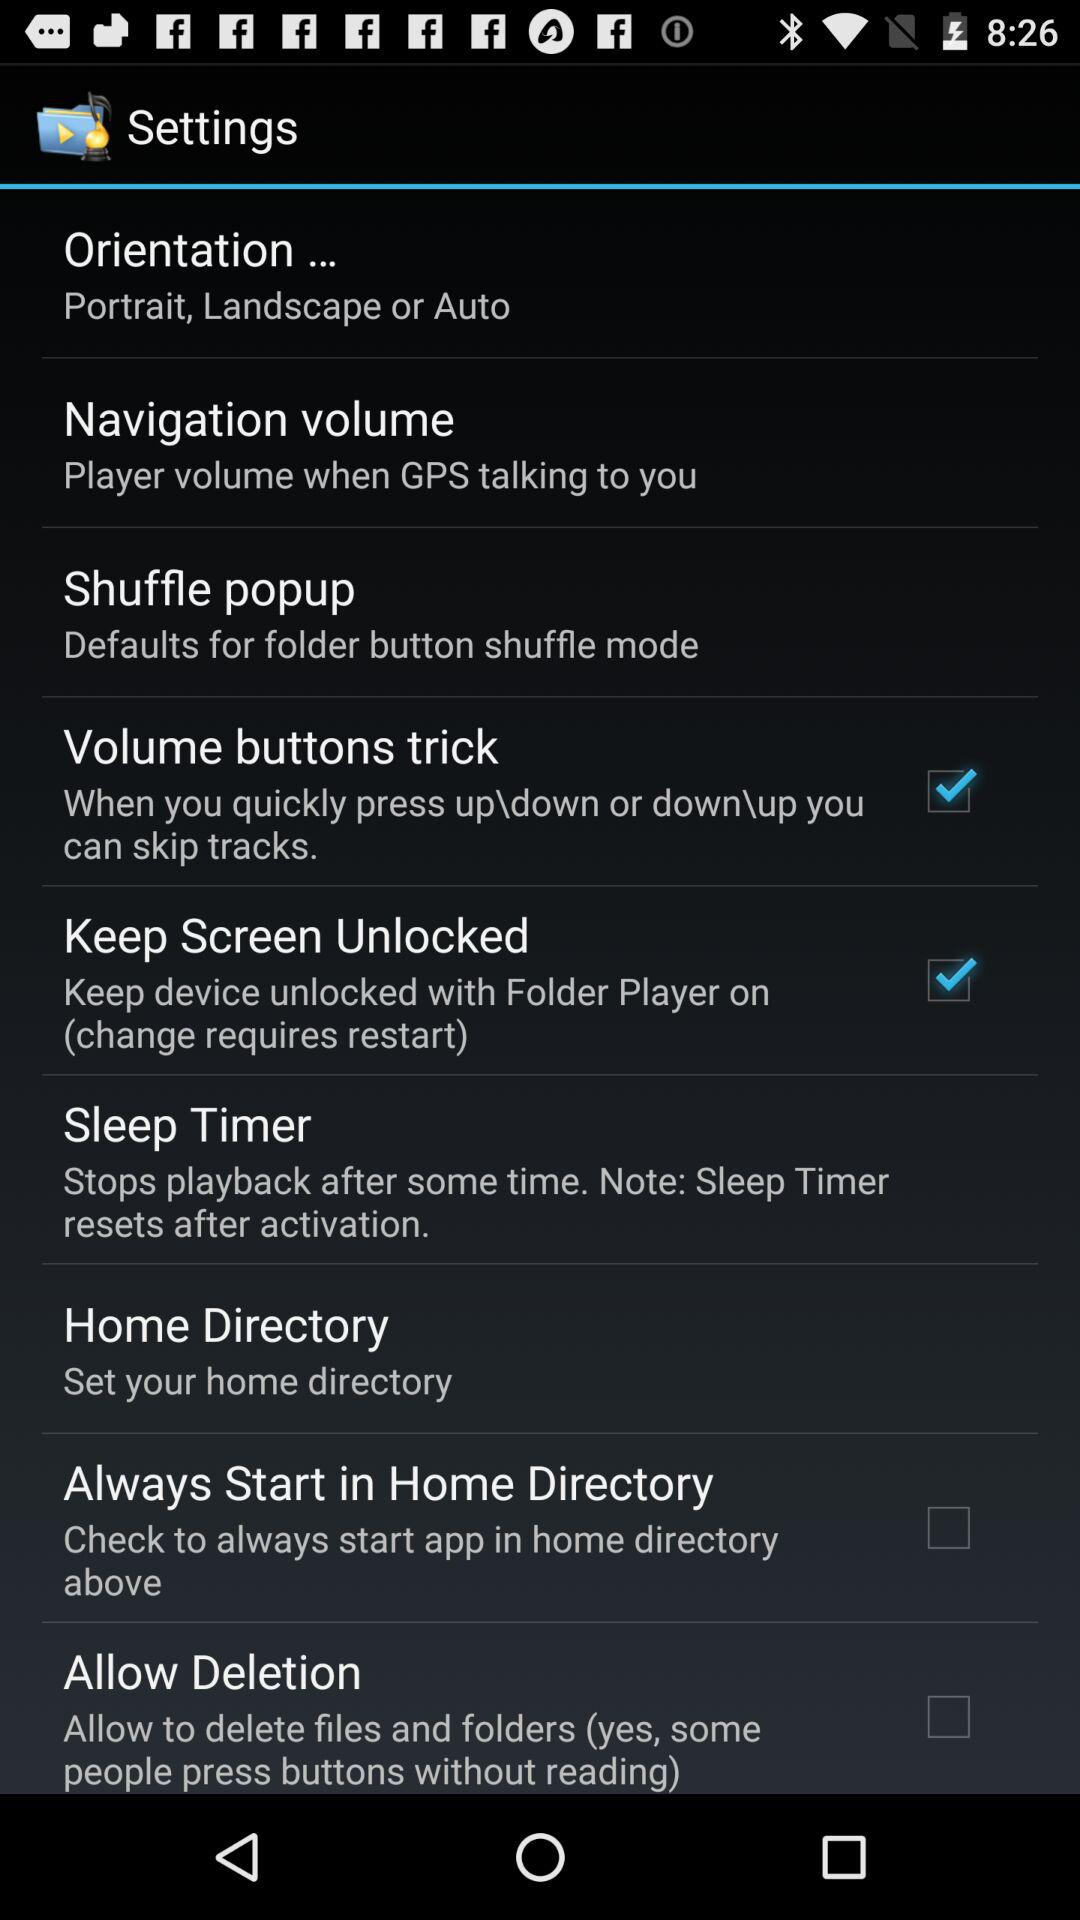What is the status of the "Volume buttons trick"? The status is "on". 